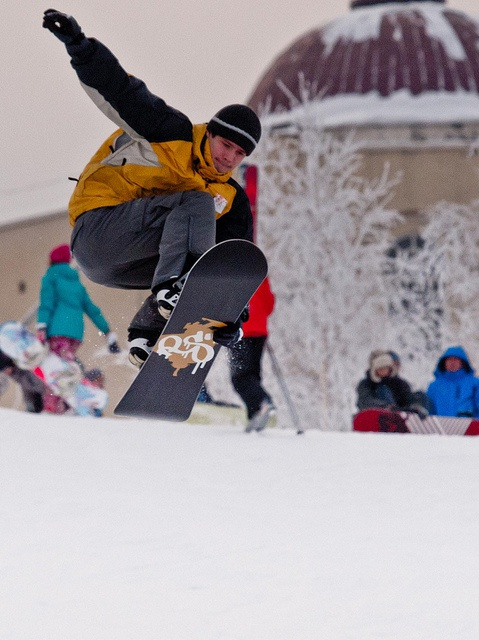Describe the objects in this image and their specific colors. I can see people in lightgray, black, olive, and gray tones, snowboard in lightgray, black, and gray tones, skateboard in lightgray, black, and gray tones, people in lightgray, teal, and brown tones, and people in lightgray, black, brown, and darkgray tones in this image. 